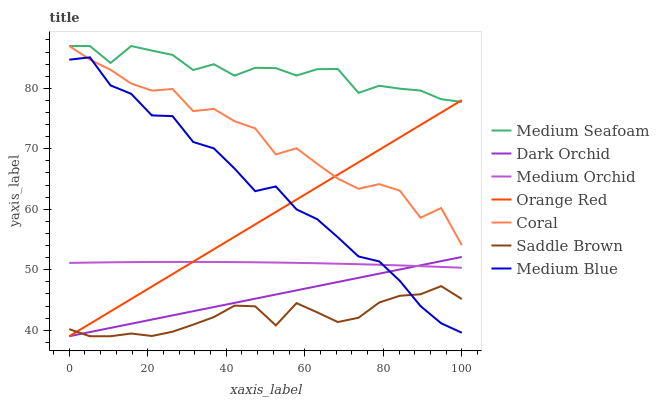Does Saddle Brown have the minimum area under the curve?
Answer yes or no. Yes. Does Medium Seafoam have the maximum area under the curve?
Answer yes or no. Yes. Does Coral have the minimum area under the curve?
Answer yes or no. No. Does Coral have the maximum area under the curve?
Answer yes or no. No. Is Dark Orchid the smoothest?
Answer yes or no. Yes. Is Coral the roughest?
Answer yes or no. Yes. Is Medium Orchid the smoothest?
Answer yes or no. No. Is Medium Orchid the roughest?
Answer yes or no. No. Does Coral have the lowest value?
Answer yes or no. No. Does Medium Seafoam have the highest value?
Answer yes or no. Yes. Does Medium Orchid have the highest value?
Answer yes or no. No. Is Dark Orchid less than Medium Seafoam?
Answer yes or no. Yes. Is Medium Orchid greater than Saddle Brown?
Answer yes or no. Yes. Does Medium Orchid intersect Orange Red?
Answer yes or no. Yes. Is Medium Orchid less than Orange Red?
Answer yes or no. No. Is Medium Orchid greater than Orange Red?
Answer yes or no. No. Does Dark Orchid intersect Medium Seafoam?
Answer yes or no. No. 